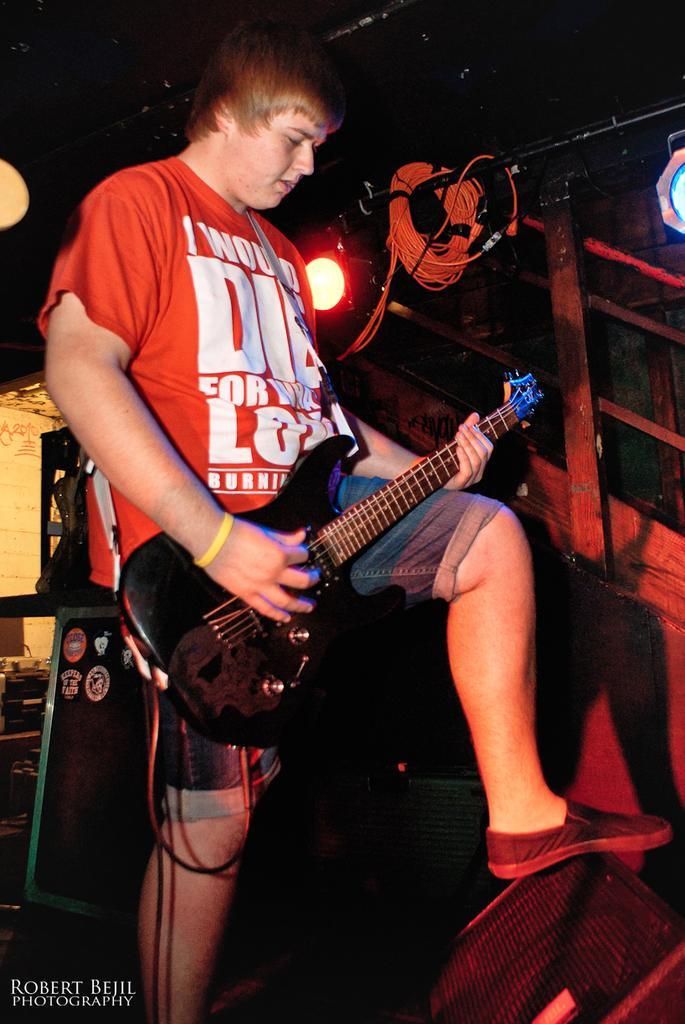In one or two sentences, can you explain what this image depicts? Here we can see a man standing on the floor and holding a guitar in his hands, and in front here is the stand, an here are the lights. 